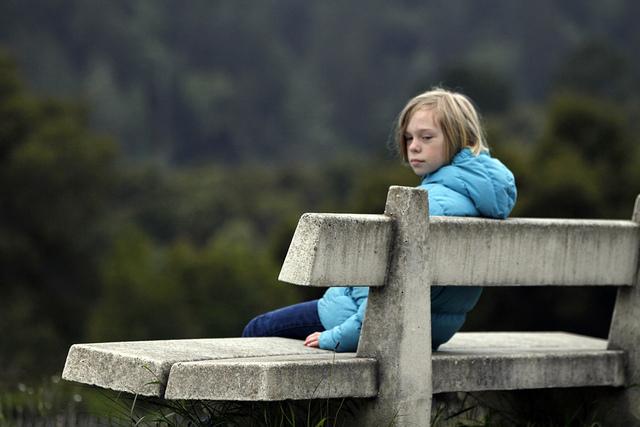What type of expression is on the girl's face?
Give a very brief answer. Sad. How many people are in the picture?
Write a very short answer. 1. Could more people fit on the bench with the girl?
Answer briefly. Yes. 